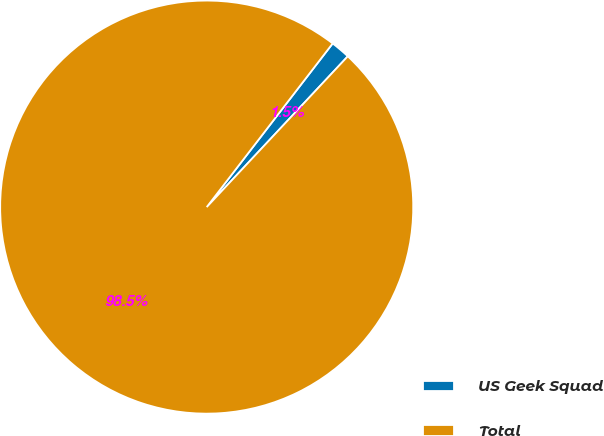Convert chart to OTSL. <chart><loc_0><loc_0><loc_500><loc_500><pie_chart><fcel>US Geek Squad<fcel>Total<nl><fcel>1.53%<fcel>98.47%<nl></chart> 